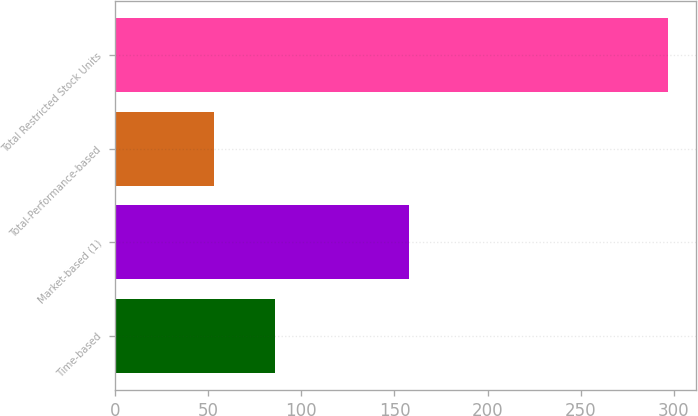<chart> <loc_0><loc_0><loc_500><loc_500><bar_chart><fcel>Time-based<fcel>Market-based (1)<fcel>Total-Performance-based<fcel>Total Restricted Stock Units<nl><fcel>86<fcel>158<fcel>53<fcel>297<nl></chart> 